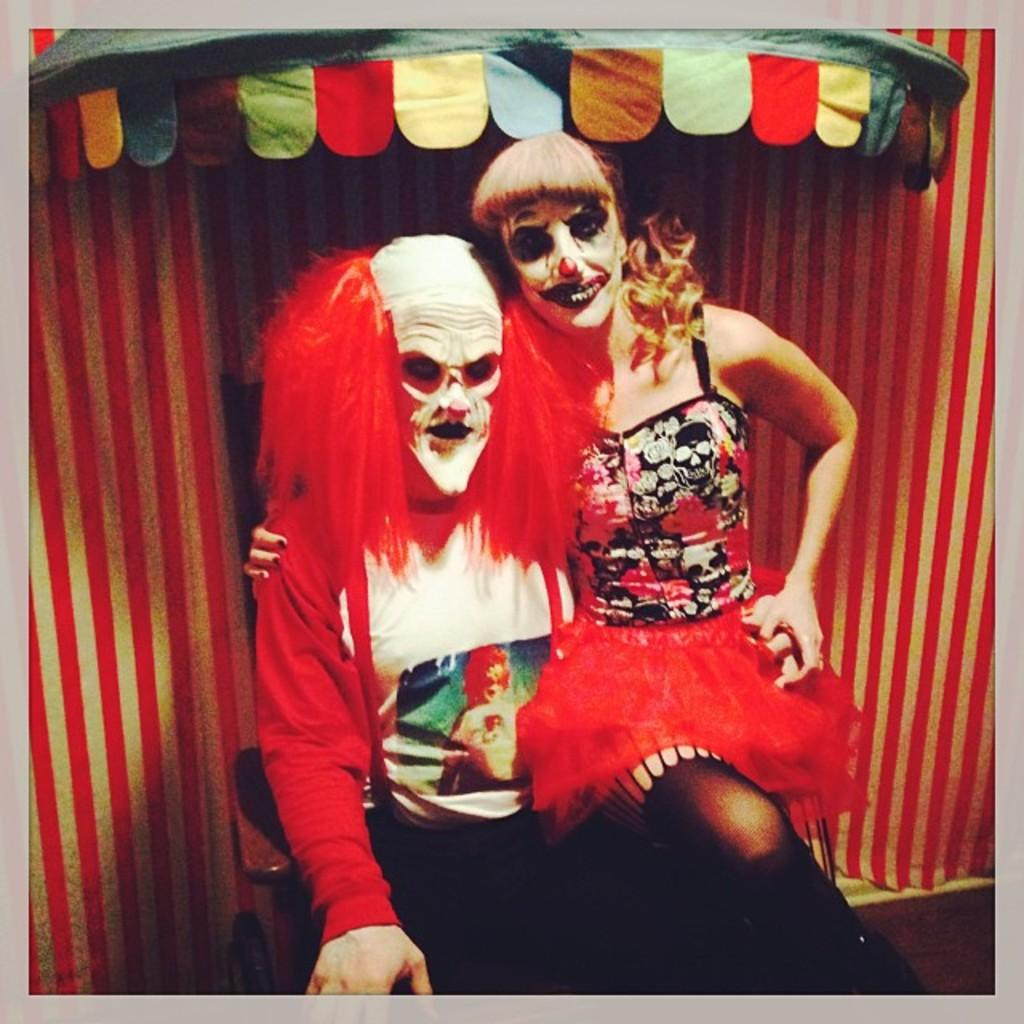How many people are sitting in the image? There are two persons sitting on chairs in the image. What can be seen in the background of the image? There is a tent visible in the background of the image. What is the surface on which the chairs are placed? There is a floor at the bottom of the image. What type of sofa can be seen in the image? There is no sofa present in the image; it features two persons sitting on chairs. What border is visible around the image? The image does not have a visible border; it is a photograph or illustration with edges that are not part of the scene. 